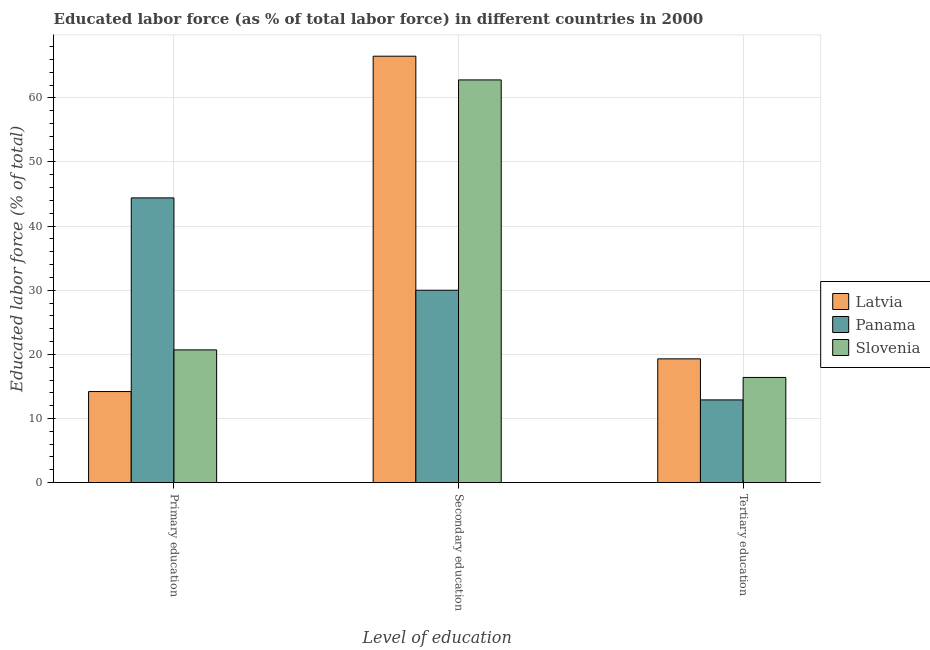How many different coloured bars are there?
Provide a succinct answer. 3. Are the number of bars per tick equal to the number of legend labels?
Offer a very short reply. Yes. Are the number of bars on each tick of the X-axis equal?
Ensure brevity in your answer.  Yes. How many bars are there on the 2nd tick from the left?
Give a very brief answer. 3. What is the label of the 3rd group of bars from the left?
Keep it short and to the point. Tertiary education. What is the percentage of labor force who received tertiary education in Panama?
Offer a very short reply. 12.9. Across all countries, what is the maximum percentage of labor force who received primary education?
Provide a succinct answer. 44.4. Across all countries, what is the minimum percentage of labor force who received primary education?
Keep it short and to the point. 14.2. In which country was the percentage of labor force who received tertiary education maximum?
Give a very brief answer. Latvia. In which country was the percentage of labor force who received tertiary education minimum?
Your response must be concise. Panama. What is the total percentage of labor force who received tertiary education in the graph?
Your answer should be compact. 48.6. What is the difference between the percentage of labor force who received tertiary education in Slovenia and that in Panama?
Your answer should be compact. 3.5. What is the difference between the percentage of labor force who received secondary education in Latvia and the percentage of labor force who received tertiary education in Slovenia?
Your response must be concise. 50.1. What is the average percentage of labor force who received primary education per country?
Give a very brief answer. 26.43. What is the difference between the percentage of labor force who received secondary education and percentage of labor force who received tertiary education in Latvia?
Make the answer very short. 47.2. What is the ratio of the percentage of labor force who received secondary education in Slovenia to that in Panama?
Your response must be concise. 2.09. Is the percentage of labor force who received tertiary education in Latvia less than that in Slovenia?
Your response must be concise. No. What is the difference between the highest and the second highest percentage of labor force who received tertiary education?
Make the answer very short. 2.9. What is the difference between the highest and the lowest percentage of labor force who received primary education?
Provide a short and direct response. 30.2. Is the sum of the percentage of labor force who received primary education in Latvia and Panama greater than the maximum percentage of labor force who received secondary education across all countries?
Offer a very short reply. No. What does the 2nd bar from the left in Secondary education represents?
Offer a very short reply. Panama. What does the 1st bar from the right in Secondary education represents?
Your response must be concise. Slovenia. Is it the case that in every country, the sum of the percentage of labor force who received primary education and percentage of labor force who received secondary education is greater than the percentage of labor force who received tertiary education?
Offer a very short reply. Yes. Are all the bars in the graph horizontal?
Offer a very short reply. No. Are the values on the major ticks of Y-axis written in scientific E-notation?
Provide a succinct answer. No. Does the graph contain any zero values?
Ensure brevity in your answer.  No. Does the graph contain grids?
Keep it short and to the point. Yes. What is the title of the graph?
Your response must be concise. Educated labor force (as % of total labor force) in different countries in 2000. Does "United States" appear as one of the legend labels in the graph?
Give a very brief answer. No. What is the label or title of the X-axis?
Keep it short and to the point. Level of education. What is the label or title of the Y-axis?
Give a very brief answer. Educated labor force (% of total). What is the Educated labor force (% of total) in Latvia in Primary education?
Provide a short and direct response. 14.2. What is the Educated labor force (% of total) in Panama in Primary education?
Provide a succinct answer. 44.4. What is the Educated labor force (% of total) in Slovenia in Primary education?
Give a very brief answer. 20.7. What is the Educated labor force (% of total) in Latvia in Secondary education?
Offer a terse response. 66.5. What is the Educated labor force (% of total) in Slovenia in Secondary education?
Give a very brief answer. 62.8. What is the Educated labor force (% of total) in Latvia in Tertiary education?
Provide a short and direct response. 19.3. What is the Educated labor force (% of total) in Panama in Tertiary education?
Give a very brief answer. 12.9. What is the Educated labor force (% of total) of Slovenia in Tertiary education?
Offer a very short reply. 16.4. Across all Level of education, what is the maximum Educated labor force (% of total) in Latvia?
Make the answer very short. 66.5. Across all Level of education, what is the maximum Educated labor force (% of total) of Panama?
Your answer should be compact. 44.4. Across all Level of education, what is the maximum Educated labor force (% of total) of Slovenia?
Your response must be concise. 62.8. Across all Level of education, what is the minimum Educated labor force (% of total) in Latvia?
Give a very brief answer. 14.2. Across all Level of education, what is the minimum Educated labor force (% of total) of Panama?
Give a very brief answer. 12.9. Across all Level of education, what is the minimum Educated labor force (% of total) of Slovenia?
Offer a terse response. 16.4. What is the total Educated labor force (% of total) of Panama in the graph?
Provide a short and direct response. 87.3. What is the total Educated labor force (% of total) of Slovenia in the graph?
Your answer should be compact. 99.9. What is the difference between the Educated labor force (% of total) of Latvia in Primary education and that in Secondary education?
Offer a very short reply. -52.3. What is the difference between the Educated labor force (% of total) in Panama in Primary education and that in Secondary education?
Provide a short and direct response. 14.4. What is the difference between the Educated labor force (% of total) of Slovenia in Primary education and that in Secondary education?
Provide a succinct answer. -42.1. What is the difference between the Educated labor force (% of total) in Latvia in Primary education and that in Tertiary education?
Offer a terse response. -5.1. What is the difference between the Educated labor force (% of total) in Panama in Primary education and that in Tertiary education?
Give a very brief answer. 31.5. What is the difference between the Educated labor force (% of total) of Latvia in Secondary education and that in Tertiary education?
Ensure brevity in your answer.  47.2. What is the difference between the Educated labor force (% of total) of Slovenia in Secondary education and that in Tertiary education?
Provide a short and direct response. 46.4. What is the difference between the Educated labor force (% of total) in Latvia in Primary education and the Educated labor force (% of total) in Panama in Secondary education?
Provide a succinct answer. -15.8. What is the difference between the Educated labor force (% of total) in Latvia in Primary education and the Educated labor force (% of total) in Slovenia in Secondary education?
Make the answer very short. -48.6. What is the difference between the Educated labor force (% of total) of Panama in Primary education and the Educated labor force (% of total) of Slovenia in Secondary education?
Provide a short and direct response. -18.4. What is the difference between the Educated labor force (% of total) of Latvia in Primary education and the Educated labor force (% of total) of Panama in Tertiary education?
Make the answer very short. 1.3. What is the difference between the Educated labor force (% of total) in Panama in Primary education and the Educated labor force (% of total) in Slovenia in Tertiary education?
Your answer should be very brief. 28. What is the difference between the Educated labor force (% of total) of Latvia in Secondary education and the Educated labor force (% of total) of Panama in Tertiary education?
Offer a terse response. 53.6. What is the difference between the Educated labor force (% of total) in Latvia in Secondary education and the Educated labor force (% of total) in Slovenia in Tertiary education?
Your answer should be compact. 50.1. What is the difference between the Educated labor force (% of total) of Panama in Secondary education and the Educated labor force (% of total) of Slovenia in Tertiary education?
Your answer should be compact. 13.6. What is the average Educated labor force (% of total) in Latvia per Level of education?
Keep it short and to the point. 33.33. What is the average Educated labor force (% of total) in Panama per Level of education?
Provide a short and direct response. 29.1. What is the average Educated labor force (% of total) of Slovenia per Level of education?
Your answer should be very brief. 33.3. What is the difference between the Educated labor force (% of total) of Latvia and Educated labor force (% of total) of Panama in Primary education?
Keep it short and to the point. -30.2. What is the difference between the Educated labor force (% of total) in Latvia and Educated labor force (% of total) in Slovenia in Primary education?
Your answer should be compact. -6.5. What is the difference between the Educated labor force (% of total) of Panama and Educated labor force (% of total) of Slovenia in Primary education?
Give a very brief answer. 23.7. What is the difference between the Educated labor force (% of total) of Latvia and Educated labor force (% of total) of Panama in Secondary education?
Ensure brevity in your answer.  36.5. What is the difference between the Educated labor force (% of total) in Latvia and Educated labor force (% of total) in Slovenia in Secondary education?
Your answer should be compact. 3.7. What is the difference between the Educated labor force (% of total) of Panama and Educated labor force (% of total) of Slovenia in Secondary education?
Provide a short and direct response. -32.8. What is the difference between the Educated labor force (% of total) of Panama and Educated labor force (% of total) of Slovenia in Tertiary education?
Provide a succinct answer. -3.5. What is the ratio of the Educated labor force (% of total) in Latvia in Primary education to that in Secondary education?
Your answer should be very brief. 0.21. What is the ratio of the Educated labor force (% of total) in Panama in Primary education to that in Secondary education?
Provide a short and direct response. 1.48. What is the ratio of the Educated labor force (% of total) of Slovenia in Primary education to that in Secondary education?
Your response must be concise. 0.33. What is the ratio of the Educated labor force (% of total) in Latvia in Primary education to that in Tertiary education?
Keep it short and to the point. 0.74. What is the ratio of the Educated labor force (% of total) in Panama in Primary education to that in Tertiary education?
Your response must be concise. 3.44. What is the ratio of the Educated labor force (% of total) in Slovenia in Primary education to that in Tertiary education?
Give a very brief answer. 1.26. What is the ratio of the Educated labor force (% of total) in Latvia in Secondary education to that in Tertiary education?
Your response must be concise. 3.45. What is the ratio of the Educated labor force (% of total) in Panama in Secondary education to that in Tertiary education?
Ensure brevity in your answer.  2.33. What is the ratio of the Educated labor force (% of total) of Slovenia in Secondary education to that in Tertiary education?
Give a very brief answer. 3.83. What is the difference between the highest and the second highest Educated labor force (% of total) in Latvia?
Your answer should be very brief. 47.2. What is the difference between the highest and the second highest Educated labor force (% of total) of Panama?
Your answer should be very brief. 14.4. What is the difference between the highest and the second highest Educated labor force (% of total) in Slovenia?
Provide a succinct answer. 42.1. What is the difference between the highest and the lowest Educated labor force (% of total) of Latvia?
Provide a succinct answer. 52.3. What is the difference between the highest and the lowest Educated labor force (% of total) of Panama?
Make the answer very short. 31.5. What is the difference between the highest and the lowest Educated labor force (% of total) of Slovenia?
Your answer should be compact. 46.4. 